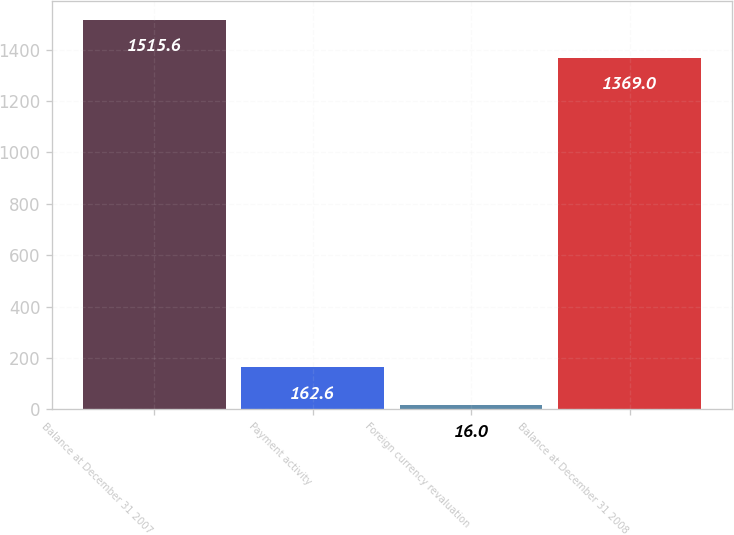<chart> <loc_0><loc_0><loc_500><loc_500><bar_chart><fcel>Balance at December 31 2007<fcel>Payment activity<fcel>Foreign currency revaluation<fcel>Balance at December 31 2008<nl><fcel>1515.6<fcel>162.6<fcel>16<fcel>1369<nl></chart> 